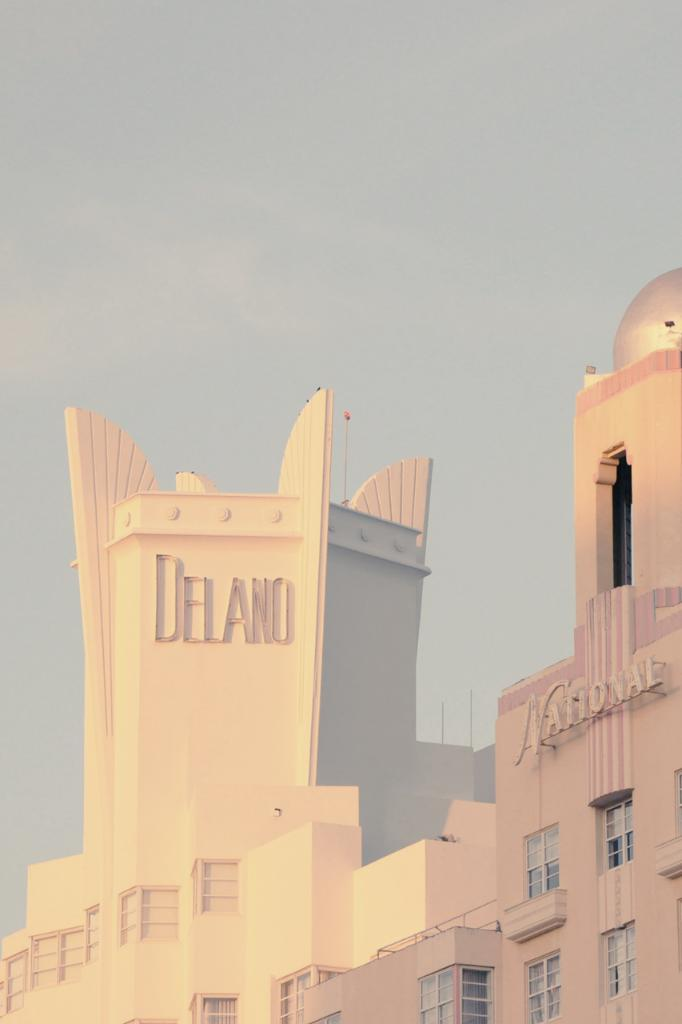What is the main structure in the image? There is a building in the image. What feature can be seen on the building? The building has windows. Are there any words or names on the building? Yes, there are names on the building. What can be seen in the background of the image? The sky is visible in the background of the image. What is the price of the trick brake shown in the image? There is no trick brake present in the image, so it is not possible to determine its price. 